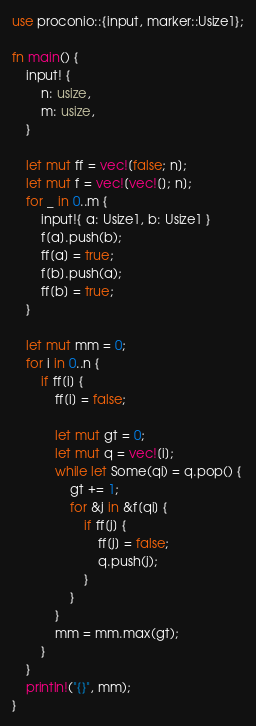Convert code to text. <code><loc_0><loc_0><loc_500><loc_500><_Rust_>use proconio::{input, marker::Usize1};

fn main() {
    input! {
        n: usize,
        m: usize,
    }

    let mut ff = vec![false; n];
    let mut f = vec![vec![]; n];
    for _ in 0..m {
        input!{ a: Usize1, b: Usize1 }
        f[a].push(b);
        ff[a] = true;
        f[b].push(a);
        ff[b] = true;
    }

    let mut mm = 0;
    for i in 0..n {
        if ff[i] {
            ff[i] = false;

            let mut gt = 0;
            let mut q = vec![i];
            while let Some(qi) = q.pop() {
                gt += 1;
                for &j in &f[qi] {
                    if ff[j] {
                        ff[j] = false;
                        q.push(j);
                    }
                }
            }
            mm = mm.max(gt);
        }
    }
    println!("{}", mm);
}
</code> 